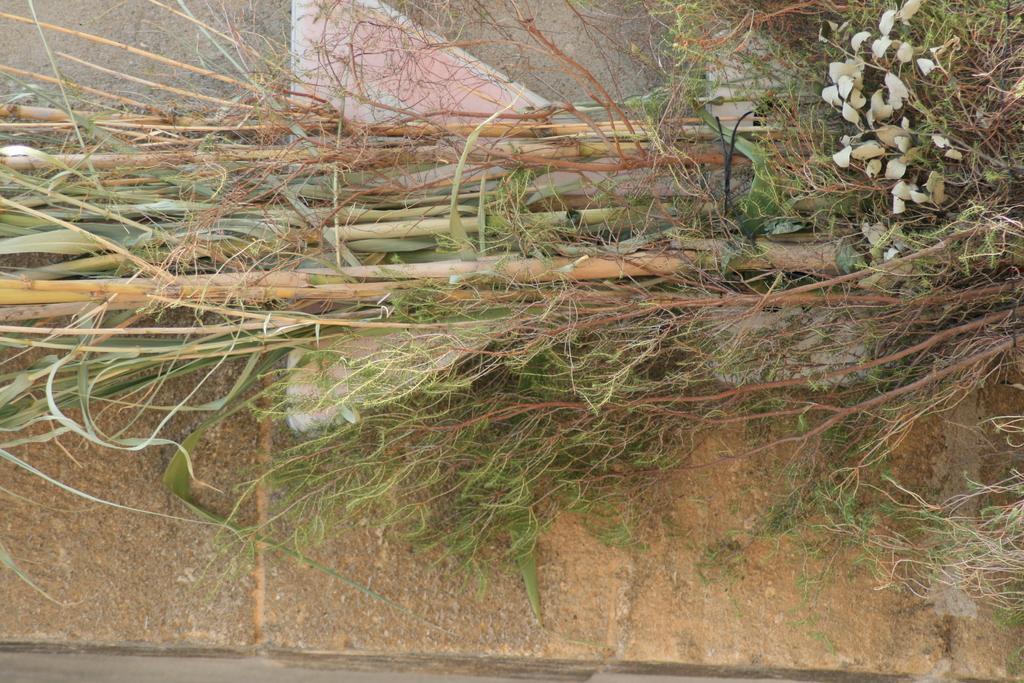How would you summarize this image in a sentence or two? In this picture we can see some sugarcane and leaves here, there is a wall in the background. 